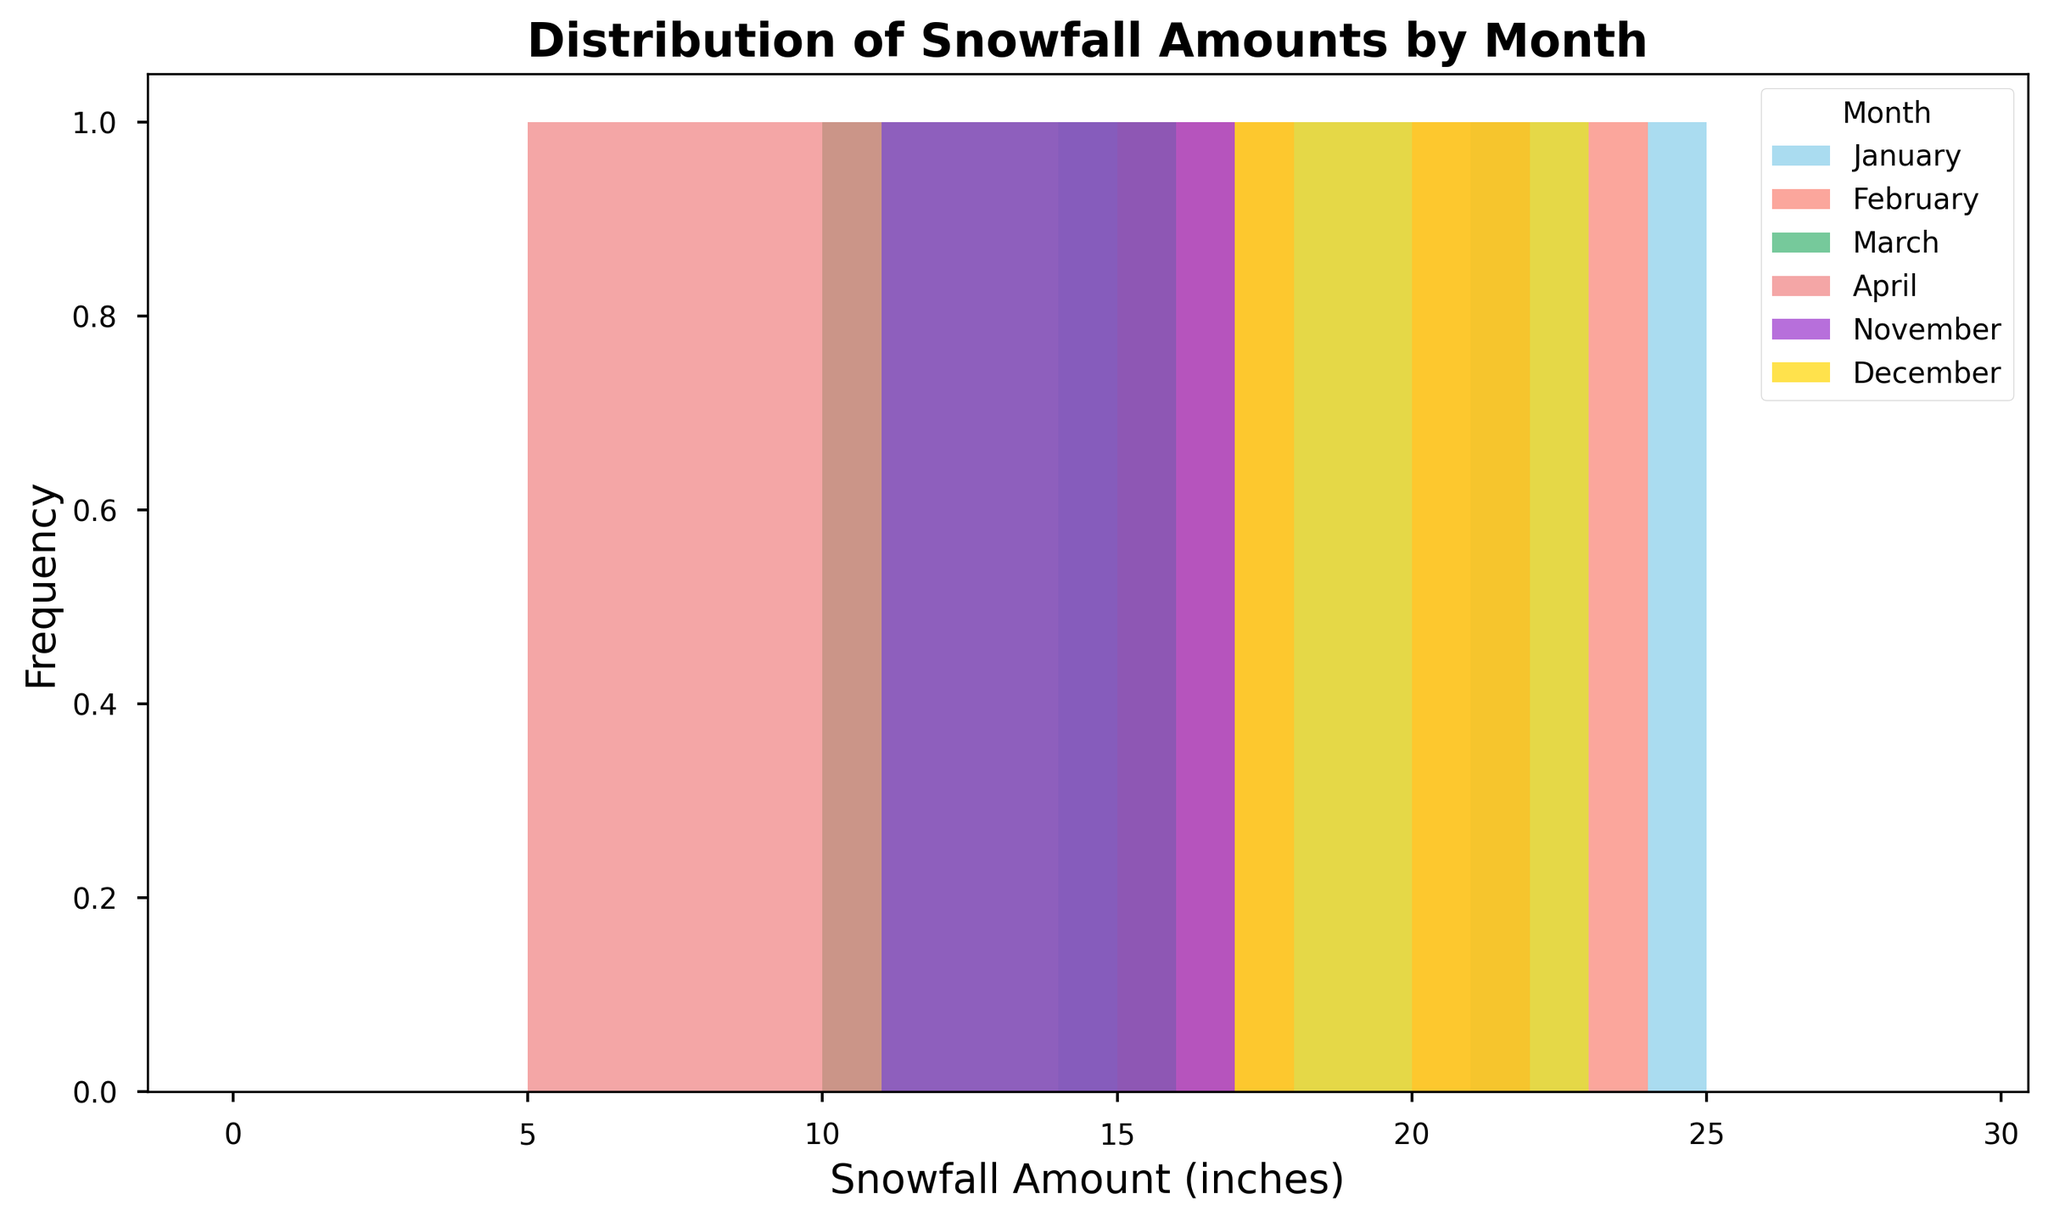What is the most frequent snowfall amount in January? Observing the histogram, identify the tallest bar in the section representing January. The height indicates the frequency, showing which snowfall amount occurs most often.
Answer: 21 inches Which month has the greatest range of snowfall amounts? Check the spread of the snowfall on the x-axis for each month's color-coded histogram. The month with the widest range from the smallest to largest snowfall amount has the greatest range.
Answer: December How many months have a snowfall frequency peak at exactly 20 inches? Look for bars at the 20 inches mark across different months. Count how many months have their tallest bar at 20 inches.
Answer: 2 months (February and December) Which month appears to have the most consistent snowfall amounts? Analyzing the histogram, find the month where the distribution is concentrated around a specific range with less spread.
Answer: April In December, which snowfall amount is more frequent: 18 inches or 21 inches? Observe the histogram segments for December (colored gold) at 18 and 21 inches. Compare the heights of these bars to determine which one is taller.
Answer: 21 inches What is the difference between the most frequent snowfall amounts in March and January? Identify the tallest bars in March's (mediumseagreen) and January's (skyblue) sections. Note their values and calculate the difference.
Answer: 7 inches (21 - 14) Which color corresponds to the histogram bars representing snowfall data for February? Check the legend in the plot, which explains the color coding for each month. Find February's color.
Answer: Salmon List the two months with the highest frequency of snowfall amounts between 15 and 20 inches. Look at the histograms for each month within 15-20 inches. Note the months with the tallest bars in that range.
Answer: January and February In April, what is the least frequent snowfall amount recorded? For April (lightcoral), find the smallest bars and note the snowfall amounts they represent.
Answer: 6 inches Which month has the highest variability in snowfall amounts? Identify the month with the most spread out and diverse range of bar heights in the histogram, indicating higher variability.
Answer: December 